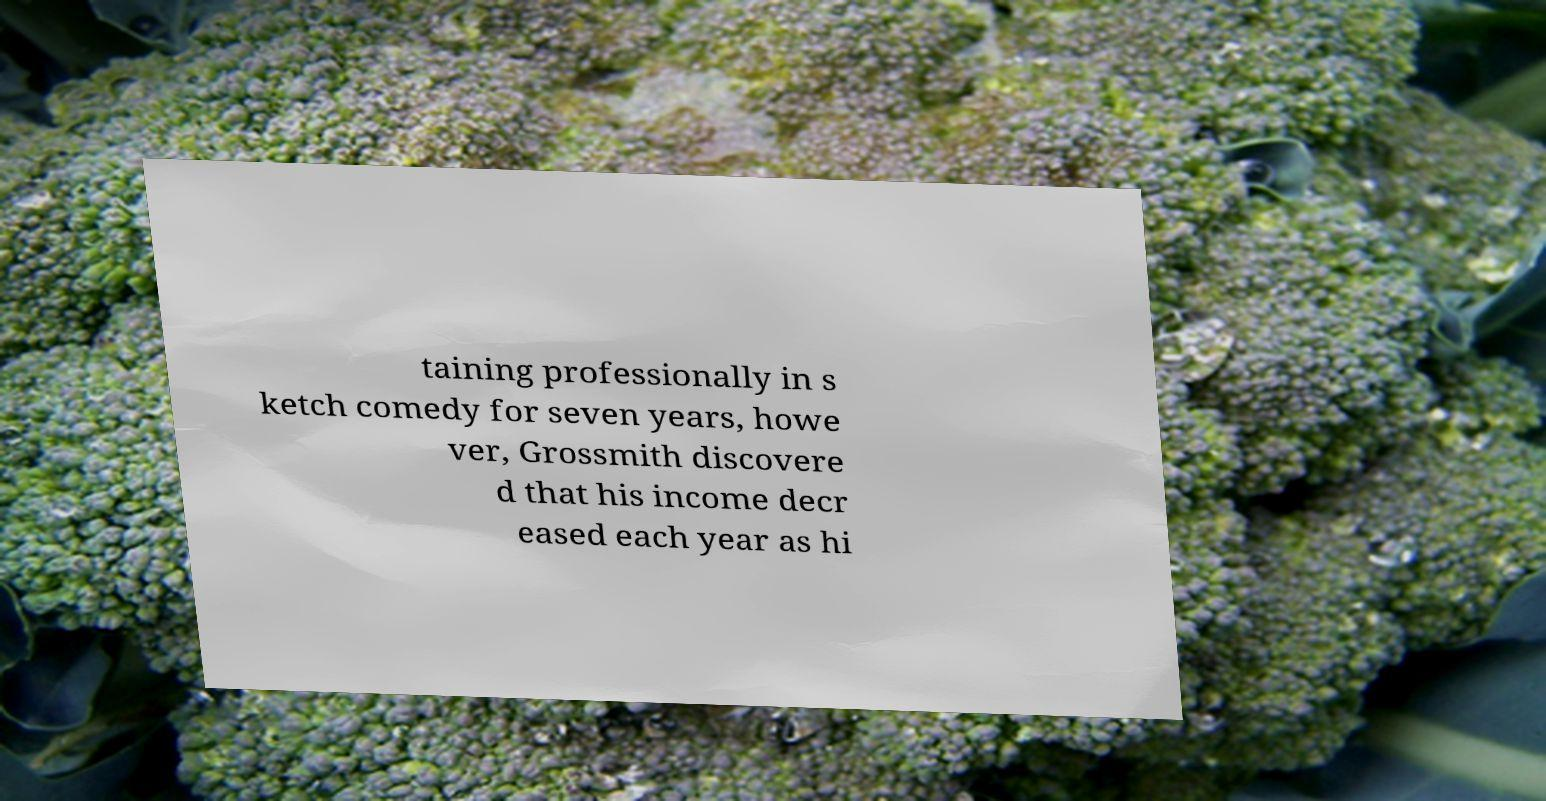What messages or text are displayed in this image? I need them in a readable, typed format. taining professionally in s ketch comedy for seven years, howe ver, Grossmith discovere d that his income decr eased each year as hi 